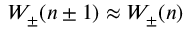Convert formula to latex. <formula><loc_0><loc_0><loc_500><loc_500>W _ { \pm } ( n \pm 1 ) \approx W _ { \pm } ( n )</formula> 